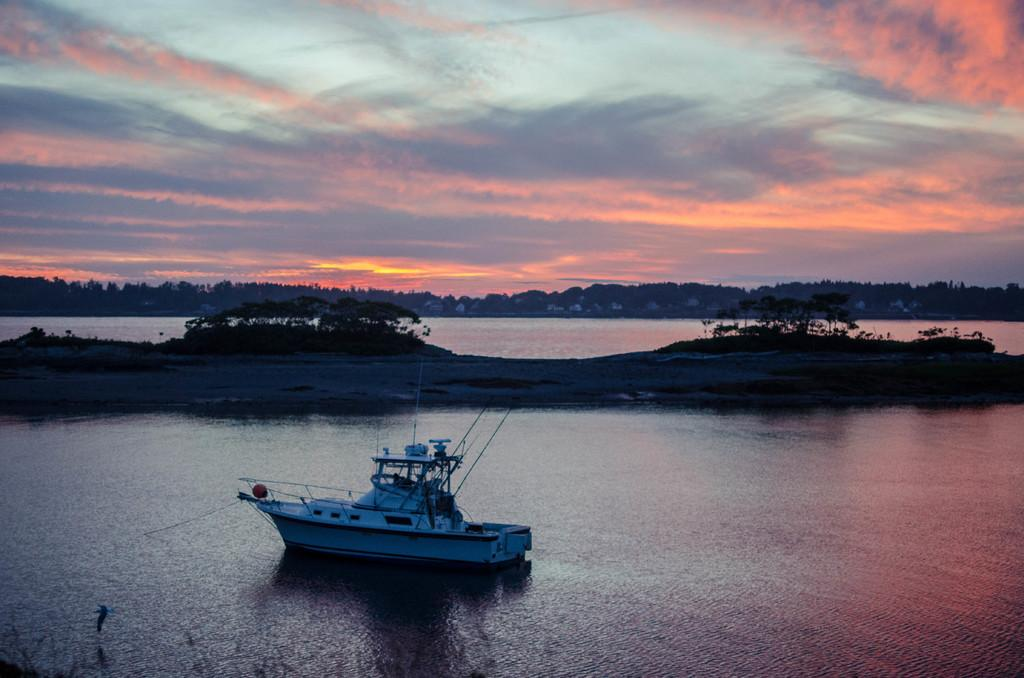What is the main subject of the image? The main subject of the image is a ship. Where is the ship located? The ship is on the water. What other objects or structures can be seen in the image? There are trees, buildings, and the sky visible in the image. Can you describe the sky in the image? The sky is visible in the image, and there are clouds present. What type of juice can be seen being poured from a key in the image? There is no juice or key present in the image. 